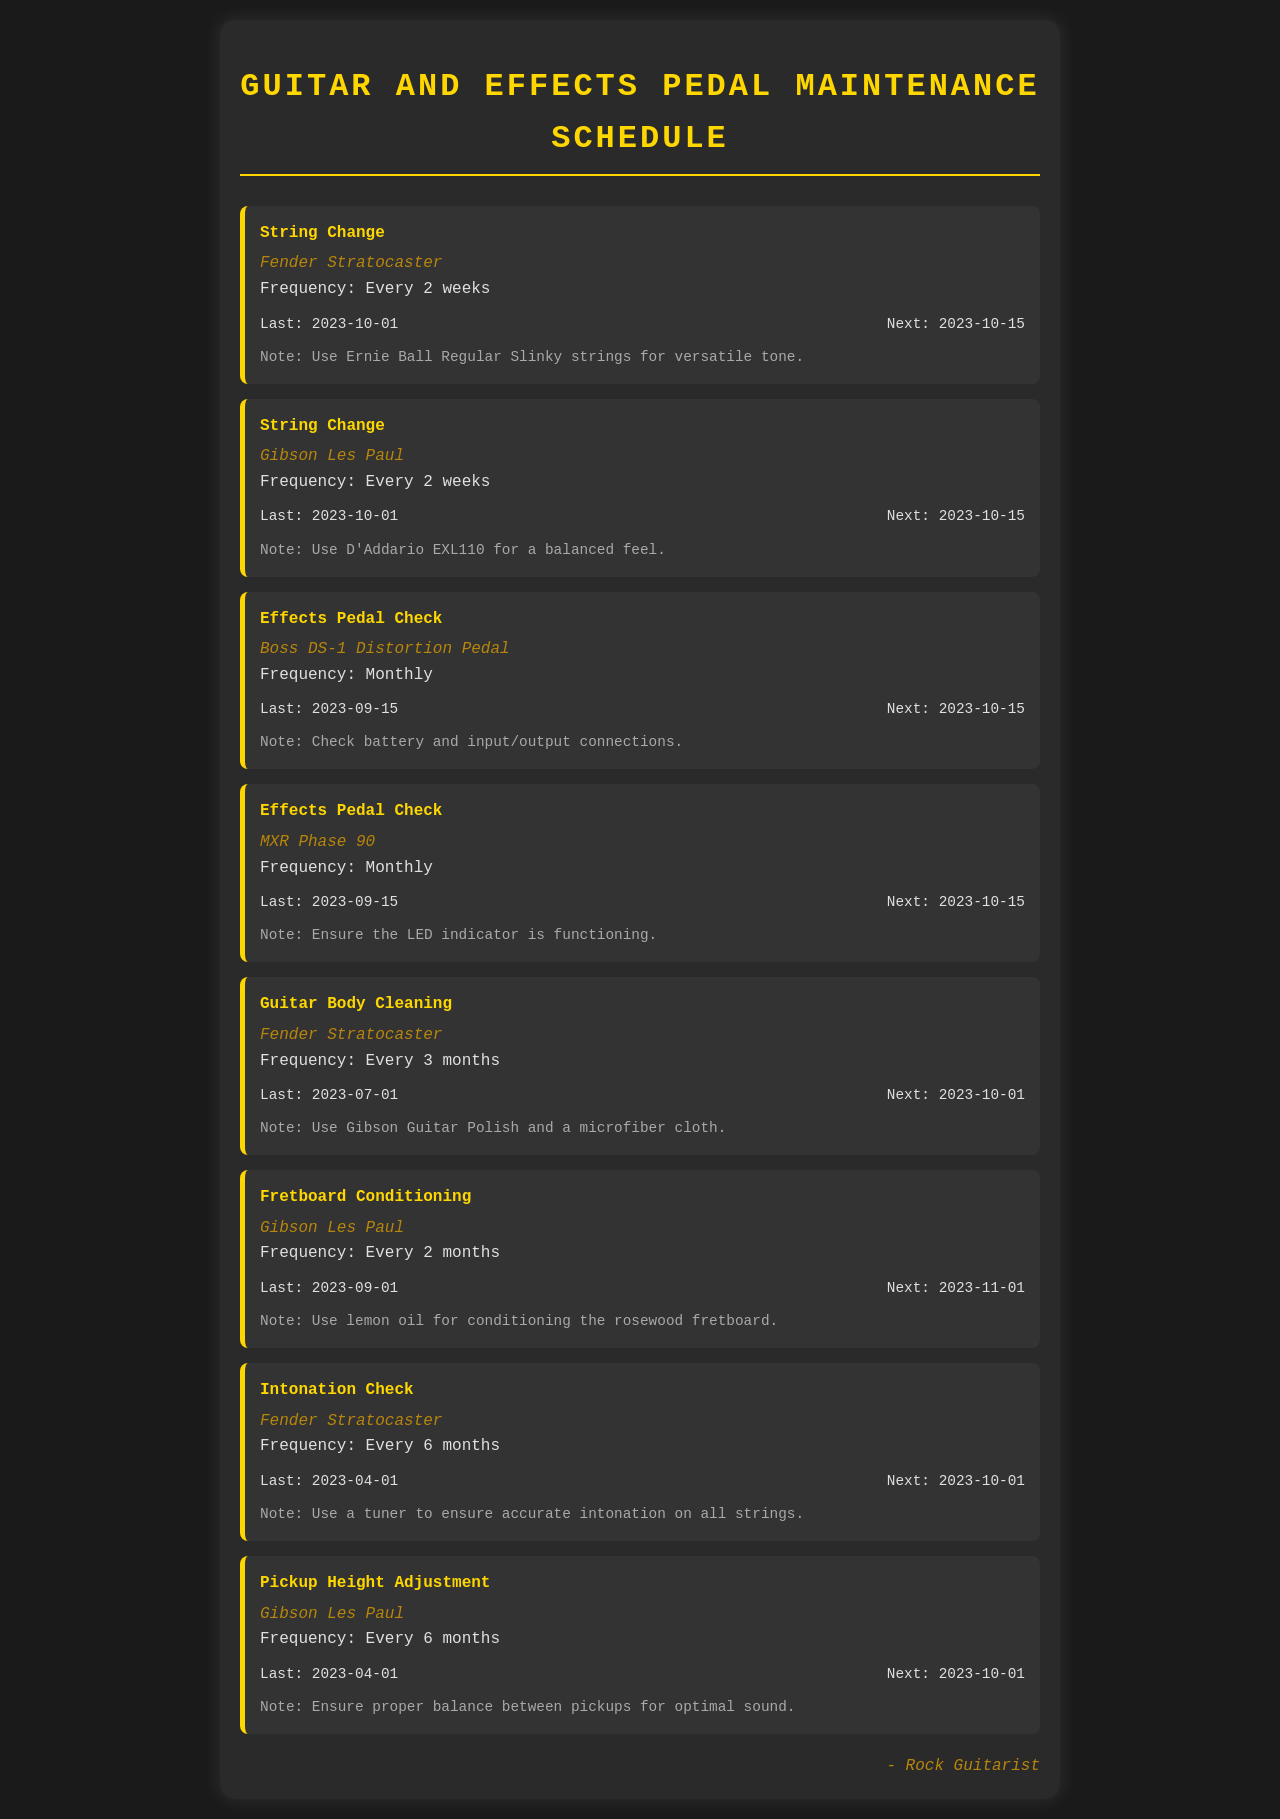what is the frequency of string changes for the Fender Stratocaster? The document states the frequency for string changes for the Fender Stratocaster is every 2 weeks.
Answer: Every 2 weeks when is the next effects pedal check for the Boss DS-1 Distortion Pedal? The next check for the Boss DS-1 Distortion Pedal is scheduled for 2023-10-15.
Answer: 2023-10-15 what note is provided for the Gibson Les Paul fretboard conditioning? The document mentions using lemon oil for conditioning the rosewood fretboard as the note for the Gibson Les Paul fretboard conditioning.
Answer: Use lemon oil how many months is the interval for guitar body cleaning of the Fender Stratocaster? The frequency for cleaning the guitar body of the Fender Stratocaster is every 3 months.
Answer: Every 3 months what was the last date for pickup height adjustment for the Gibson Les Paul? The last date noted for the pickup height adjustment of the Gibson Les Paul is 2023-04-01.
Answer: 2023-04-01 which equipment is scheduled for intonation check? The equipment listed for an intonation check is the Fender Stratocaster.
Answer: Fender Stratocaster what is the last date for the next string change for the Gibson Les Paul? The next string change for the Gibson Les Paul is on 2023-10-15.
Answer: 2023-10-15 how often should the MXR Phase 90 be checked? The frequency for checking the MXR Phase 90 is monthly.
Answer: Monthly which strings are recommended for the Fender Stratocaster? The document specifies Ernie Ball Regular Slinky strings for the Fender Stratocaster.
Answer: Ernie Ball Regular Slinky 